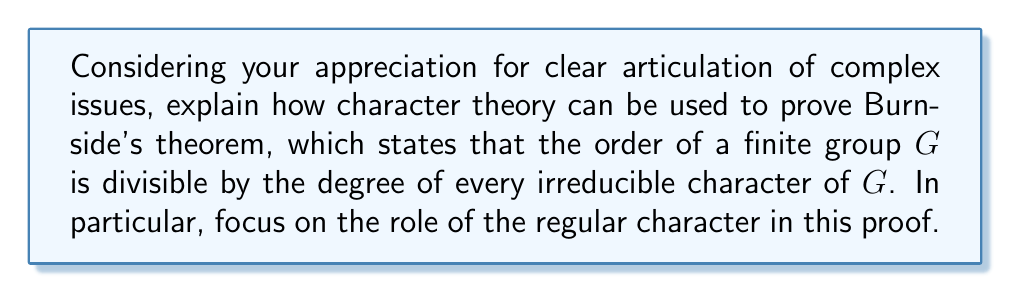Solve this math problem. To prove Burnside's theorem using character theory, we'll follow these steps:

1) First, recall that the regular character $\rho$ of a finite group $G$ is defined as:
   $$\rho(g) = \begin{cases} 
   |G| & \text{if } g = e \\
   0 & \text{if } g \neq e
   \end{cases}$$
   where $e$ is the identity element of $G$.

2) The regular character can be decomposed into irreducible characters:
   $$\rho = \sum_{\chi \in \text{Irr}(G)} \chi(1)\chi$$
   where $\text{Irr}(G)$ is the set of irreducible characters of $G$, and $\chi(1)$ is the degree of the character $\chi$.

3) Now, let's consider the inner product of $\rho$ with an irreducible character $\chi$:
   $$\langle \rho, \chi \rangle = \frac{1}{|G|} \sum_{g \in G} \rho(g)\overline{\chi(g)}$$

4) Using the definition of $\rho$, this simplifies to:
   $$\langle \rho, \chi \rangle = \frac{1}{|G|} |G| \chi(e) = \chi(1)$$

5) On the other hand, using the decomposition of $\rho$:
   $$\langle \rho, \chi \rangle = \left\langle \sum_{\psi \in \text{Irr}(G)} \psi(1)\psi, \chi \right\rangle = \chi(1)$$
   due to the orthogonality of irreducible characters.

6) Equating these results:
   $$\chi(1) = \frac{1}{|G|} |G| \chi(1)$$

7) This implies:
   $$|G| = \frac{|G|}{\chi(1)} \cdot \chi(1)$$

8) For this equation to hold, $\chi(1)$ must divide $|G|$.

This proves Burnside's theorem: the order of the group is divisible by the degree of every irreducible character.
Answer: $\chi(1)$ divides $|G|$ for all $\chi \in \text{Irr}(G)$ 